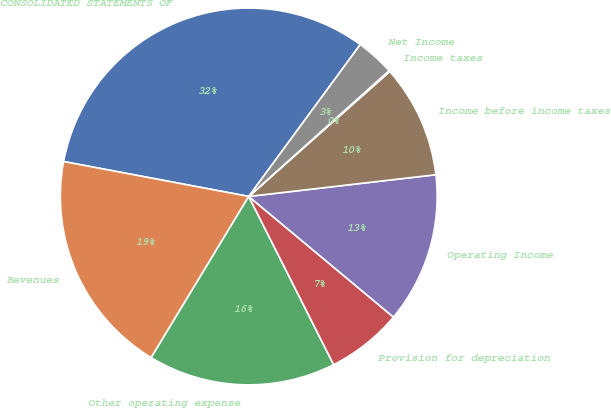Convert chart. <chart><loc_0><loc_0><loc_500><loc_500><pie_chart><fcel>CONSOLIDATED STATEMENTS OF<fcel>Revenues<fcel>Other operating expense<fcel>Provision for depreciation<fcel>Operating Income<fcel>Income before income taxes<fcel>Income taxes<fcel>Net Income<nl><fcel>32.11%<fcel>19.3%<fcel>16.1%<fcel>6.5%<fcel>12.9%<fcel>9.7%<fcel>0.09%<fcel>3.29%<nl></chart> 